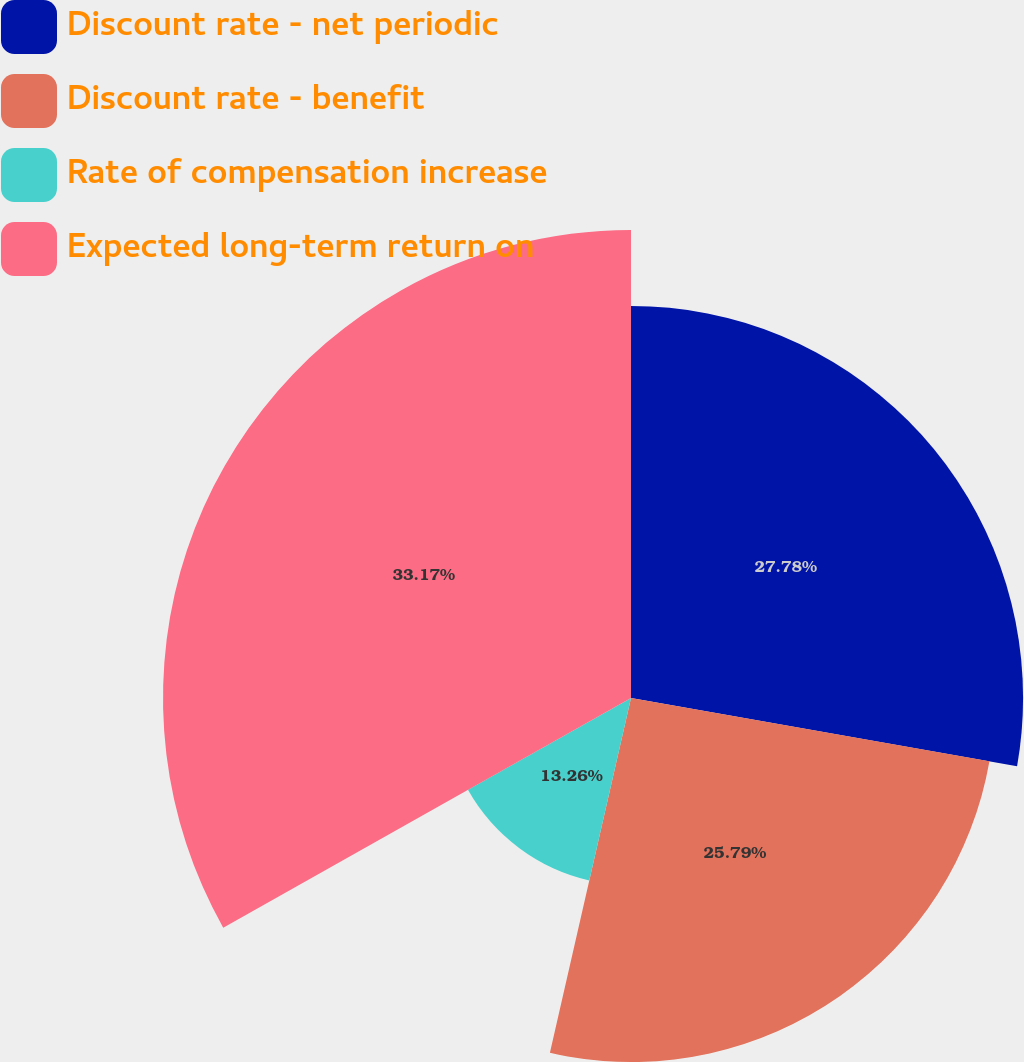<chart> <loc_0><loc_0><loc_500><loc_500><pie_chart><fcel>Discount rate - net periodic<fcel>Discount rate - benefit<fcel>Rate of compensation increase<fcel>Expected long-term return on<nl><fcel>27.78%<fcel>25.79%<fcel>13.26%<fcel>33.16%<nl></chart> 